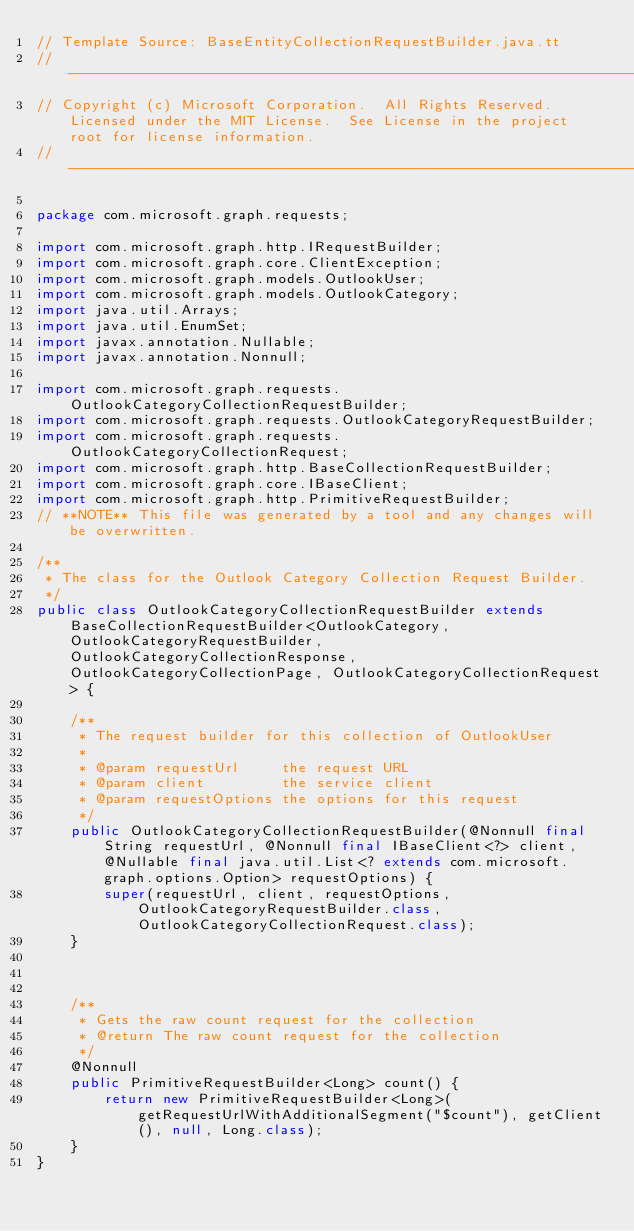Convert code to text. <code><loc_0><loc_0><loc_500><loc_500><_Java_>// Template Source: BaseEntityCollectionRequestBuilder.java.tt
// ------------------------------------------------------------------------------
// Copyright (c) Microsoft Corporation.  All Rights Reserved.  Licensed under the MIT License.  See License in the project root for license information.
// ------------------------------------------------------------------------------

package com.microsoft.graph.requests;

import com.microsoft.graph.http.IRequestBuilder;
import com.microsoft.graph.core.ClientException;
import com.microsoft.graph.models.OutlookUser;
import com.microsoft.graph.models.OutlookCategory;
import java.util.Arrays;
import java.util.EnumSet;
import javax.annotation.Nullable;
import javax.annotation.Nonnull;

import com.microsoft.graph.requests.OutlookCategoryCollectionRequestBuilder;
import com.microsoft.graph.requests.OutlookCategoryRequestBuilder;
import com.microsoft.graph.requests.OutlookCategoryCollectionRequest;
import com.microsoft.graph.http.BaseCollectionRequestBuilder;
import com.microsoft.graph.core.IBaseClient;
import com.microsoft.graph.http.PrimitiveRequestBuilder;
// **NOTE** This file was generated by a tool and any changes will be overwritten.

/**
 * The class for the Outlook Category Collection Request Builder.
 */
public class OutlookCategoryCollectionRequestBuilder extends BaseCollectionRequestBuilder<OutlookCategory, OutlookCategoryRequestBuilder, OutlookCategoryCollectionResponse, OutlookCategoryCollectionPage, OutlookCategoryCollectionRequest> {

    /**
     * The request builder for this collection of OutlookUser
     *
     * @param requestUrl     the request URL
     * @param client         the service client
     * @param requestOptions the options for this request
     */
    public OutlookCategoryCollectionRequestBuilder(@Nonnull final String requestUrl, @Nonnull final IBaseClient<?> client, @Nullable final java.util.List<? extends com.microsoft.graph.options.Option> requestOptions) {
        super(requestUrl, client, requestOptions, OutlookCategoryRequestBuilder.class, OutlookCategoryCollectionRequest.class);
    }



    /**
     * Gets the raw count request for the collection
     * @return The raw count request for the collection
     */
    @Nonnull
    public PrimitiveRequestBuilder<Long> count() {
        return new PrimitiveRequestBuilder<Long>(getRequestUrlWithAdditionalSegment("$count"), getClient(), null, Long.class);
    }
}
</code> 